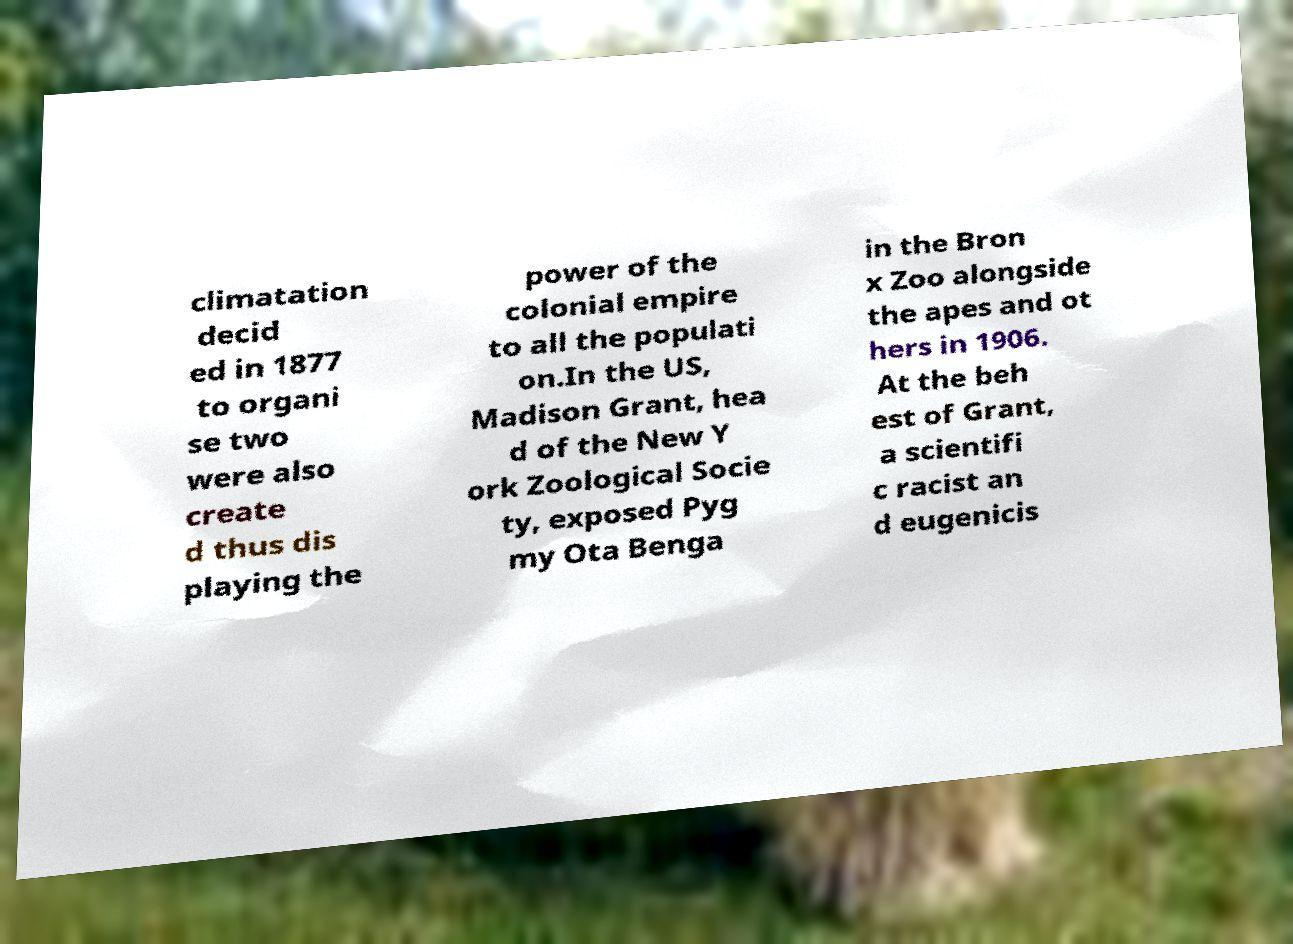Could you assist in decoding the text presented in this image and type it out clearly? climatation decid ed in 1877 to organi se two were also create d thus dis playing the power of the colonial empire to all the populati on.In the US, Madison Grant, hea d of the New Y ork Zoological Socie ty, exposed Pyg my Ota Benga in the Bron x Zoo alongside the apes and ot hers in 1906. At the beh est of Grant, a scientifi c racist an d eugenicis 